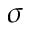<formula> <loc_0><loc_0><loc_500><loc_500>\sigma</formula> 